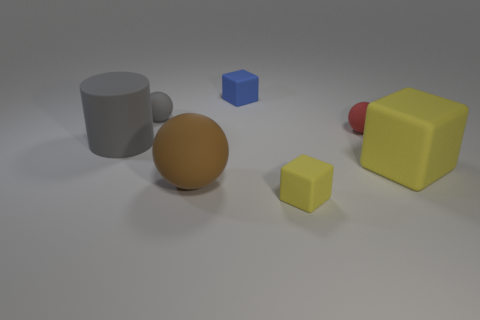What is the size of the sphere that is the same color as the rubber cylinder?
Provide a short and direct response. Small. Is the number of yellow objects greater than the number of big brown matte blocks?
Provide a succinct answer. Yes. Do the big ball and the big cube have the same color?
Give a very brief answer. No. How many objects are either big purple matte things or matte objects in front of the large cylinder?
Keep it short and to the point. 3. How many other things are the same shape as the small yellow thing?
Provide a succinct answer. 2. Is the number of small red matte things that are behind the blue rubber cube less than the number of matte things that are in front of the small gray sphere?
Ensure brevity in your answer.  Yes. Is there any other thing that has the same material as the small red sphere?
Keep it short and to the point. Yes. The tiny yellow object that is the same material as the large gray cylinder is what shape?
Offer a terse response. Cube. Is there any other thing of the same color as the matte cylinder?
Give a very brief answer. Yes. What color is the ball that is right of the matte object that is behind the gray ball?
Keep it short and to the point. Red. 